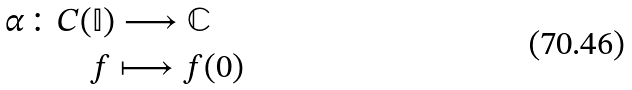Convert formula to latex. <formula><loc_0><loc_0><loc_500><loc_500>\alpha \colon & C ( \mathbb { I } ) \longrightarrow \mathbb { C } \\ & \quad f \longmapsto f ( 0 )</formula> 